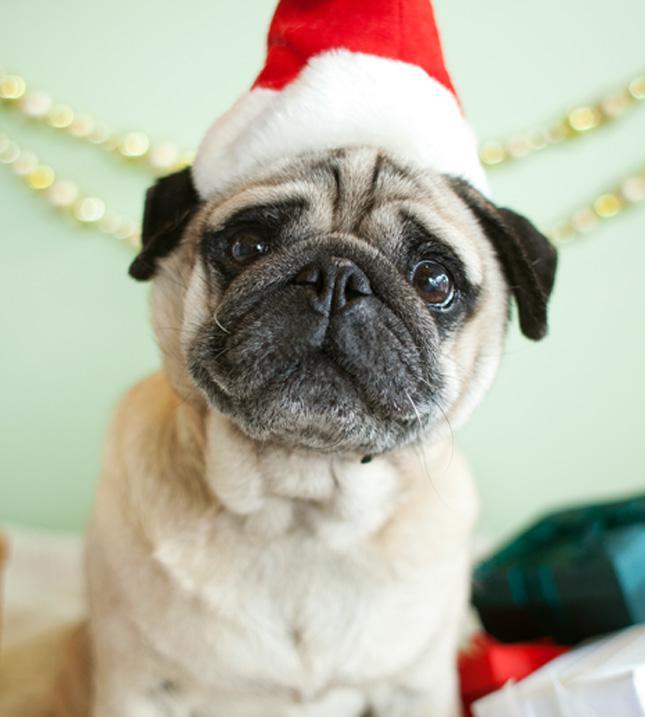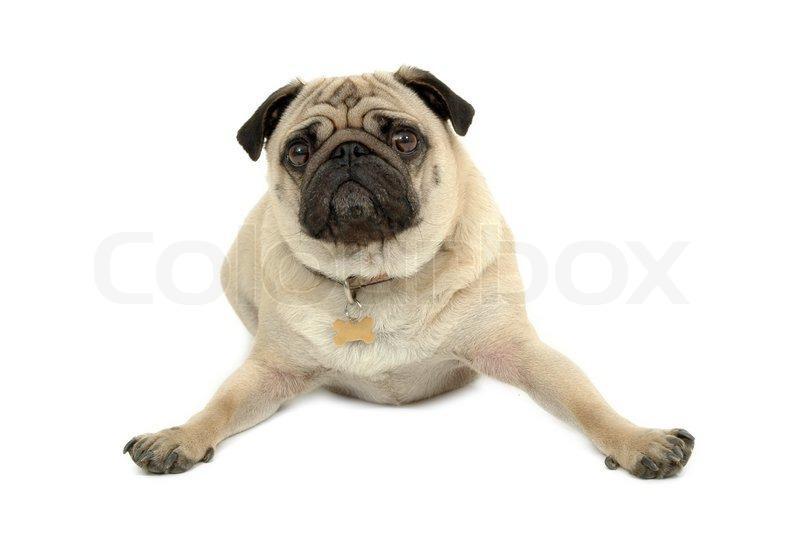The first image is the image on the left, the second image is the image on the right. For the images shown, is this caption "The pug in the right image is posed with head and body facing forward, and with his front paws extended and farther apart than its body width." true? Answer yes or no. Yes. The first image is the image on the left, the second image is the image on the right. Assess this claim about the two images: "One dog is wearing a dog collar.". Correct or not? Answer yes or no. Yes. 